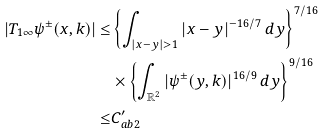Convert formula to latex. <formula><loc_0><loc_0><loc_500><loc_500>| T _ { 1 \infty } \psi ^ { \pm } ( x , k ) | \leq & \left \{ \int _ { | x - y | > 1 } | x - y | ^ { - 1 6 / 7 } \, d y \right \} ^ { 7 / 1 6 } \\ & \times \left \{ \int _ { \mathbb { R } ^ { 2 } } | \psi ^ { \pm } ( y , k ) | ^ { 1 6 / 9 } \, d y \right \} ^ { 9 / 1 6 } \\ \leq & C _ { a b 2 } ^ { \prime }</formula> 